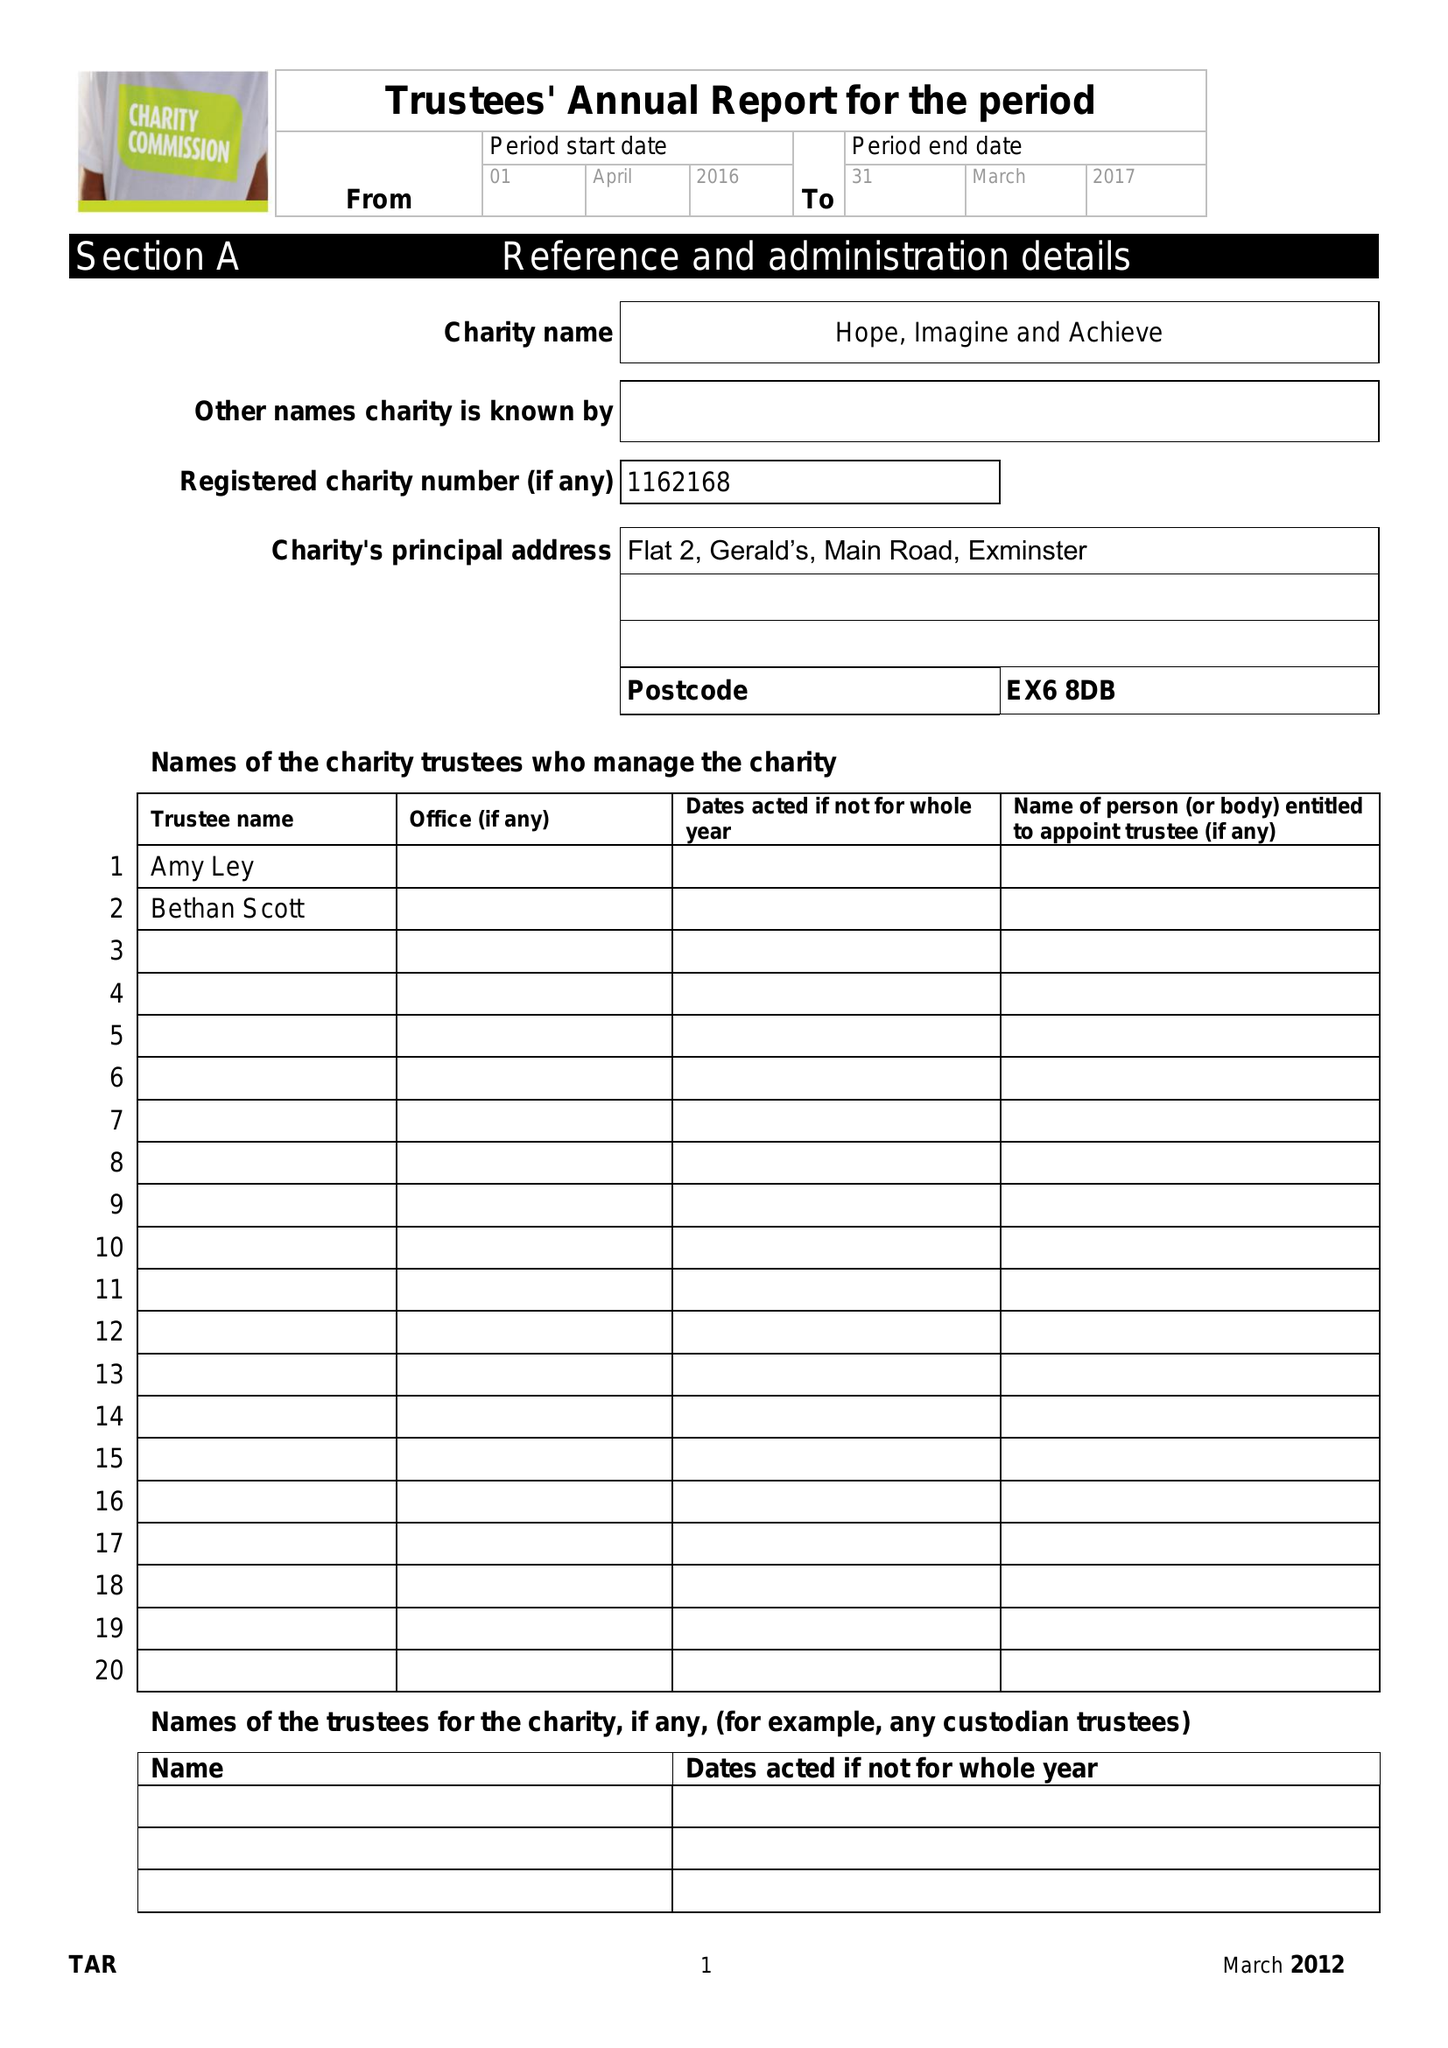What is the value for the income_annually_in_british_pounds?
Answer the question using a single word or phrase. 5134.15 